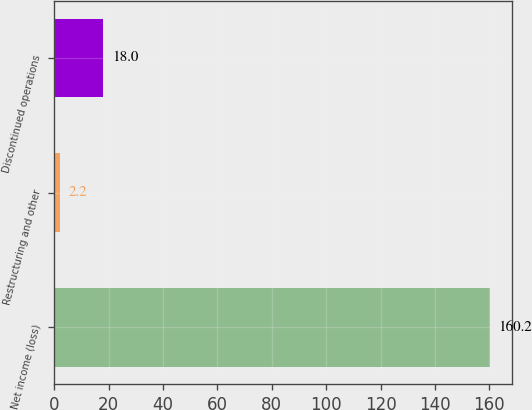Convert chart. <chart><loc_0><loc_0><loc_500><loc_500><bar_chart><fcel>Net income (loss)<fcel>Restructuring and other<fcel>Discontinued operations<nl><fcel>160.2<fcel>2.2<fcel>18<nl></chart> 